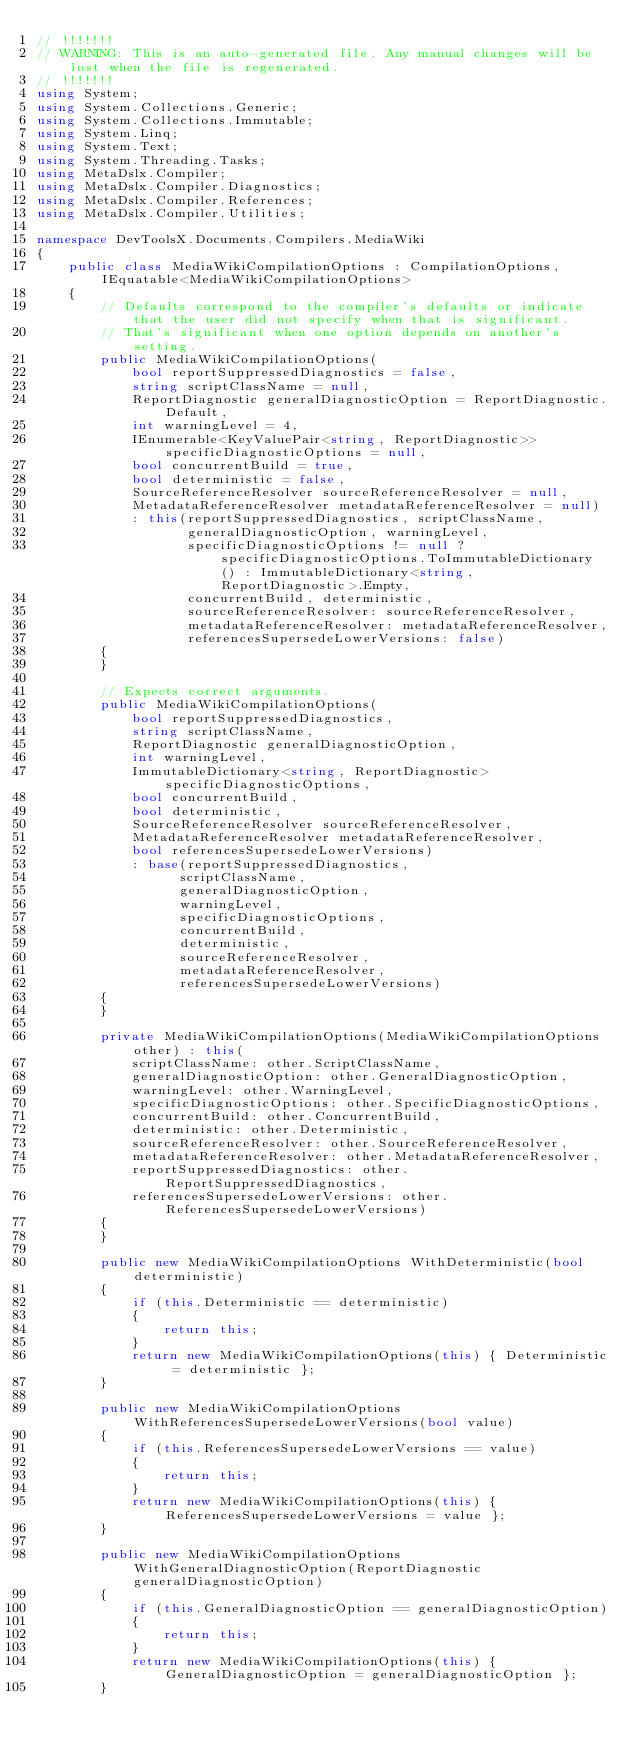<code> <loc_0><loc_0><loc_500><loc_500><_C#_>// !!!!!!!
// WARNING: This is an auto-generated file. Any manual changes will be lost when the file is regenerated.
// !!!!!!!
using System;
using System.Collections.Generic;
using System.Collections.Immutable;
using System.Linq;
using System.Text;
using System.Threading.Tasks;
using MetaDslx.Compiler;
using MetaDslx.Compiler.Diagnostics;
using MetaDslx.Compiler.References;
using MetaDslx.Compiler.Utilities;

namespace DevToolsX.Documents.Compilers.MediaWiki
{
    public class MediaWikiCompilationOptions : CompilationOptions, IEquatable<MediaWikiCompilationOptions>
    {
        // Defaults correspond to the compiler's defaults or indicate that the user did not specify when that is significant.
        // That's significant when one option depends on another's setting.
        public MediaWikiCompilationOptions(
            bool reportSuppressedDiagnostics = false,
            string scriptClassName = null,
            ReportDiagnostic generalDiagnosticOption = ReportDiagnostic.Default,
            int warningLevel = 4,
            IEnumerable<KeyValuePair<string, ReportDiagnostic>> specificDiagnosticOptions = null,
            bool concurrentBuild = true,
            bool deterministic = false,
            SourceReferenceResolver sourceReferenceResolver = null,
            MetadataReferenceResolver metadataReferenceResolver = null)
            : this(reportSuppressedDiagnostics, scriptClassName,
                   generalDiagnosticOption, warningLevel,
                   specificDiagnosticOptions != null ? specificDiagnosticOptions.ToImmutableDictionary() : ImmutableDictionary<string, ReportDiagnostic>.Empty, 
                   concurrentBuild, deterministic,
                   sourceReferenceResolver: sourceReferenceResolver,
                   metadataReferenceResolver: metadataReferenceResolver,
                   referencesSupersedeLowerVersions: false)
        {
        }

        // Expects correct arguments.
        public MediaWikiCompilationOptions(
            bool reportSuppressedDiagnostics,
            string scriptClassName,
            ReportDiagnostic generalDiagnosticOption,
            int warningLevel,
            ImmutableDictionary<string, ReportDiagnostic> specificDiagnosticOptions,
            bool concurrentBuild,
            bool deterministic,
            SourceReferenceResolver sourceReferenceResolver,
            MetadataReferenceResolver metadataReferenceResolver,
            bool referencesSupersedeLowerVersions)
            : base(reportSuppressedDiagnostics, 
                  scriptClassName,
                  generalDiagnosticOption,
                  warningLevel,
                  specificDiagnosticOptions,
                  concurrentBuild,
                  deterministic,
                  sourceReferenceResolver,
                  metadataReferenceResolver, 
                  referencesSupersedeLowerVersions)
        {
        }

        private MediaWikiCompilationOptions(MediaWikiCompilationOptions other) : this(
            scriptClassName: other.ScriptClassName,
            generalDiagnosticOption: other.GeneralDiagnosticOption,
            warningLevel: other.WarningLevel,
            specificDiagnosticOptions: other.SpecificDiagnosticOptions,
            concurrentBuild: other.ConcurrentBuild,
            deterministic: other.Deterministic,
            sourceReferenceResolver: other.SourceReferenceResolver,
            metadataReferenceResolver: other.MetadataReferenceResolver,
            reportSuppressedDiagnostics: other.ReportSuppressedDiagnostics,
            referencesSupersedeLowerVersions: other.ReferencesSupersedeLowerVersions)
        {
        }

        public new MediaWikiCompilationOptions WithDeterministic(bool deterministic)
        {
            if (this.Deterministic == deterministic)
            {
                return this;
            }
            return new MediaWikiCompilationOptions(this) { Deterministic = deterministic };
        }

        public new MediaWikiCompilationOptions WithReferencesSupersedeLowerVersions(bool value)
        {
            if (this.ReferencesSupersedeLowerVersions == value)
            {
                return this;
            }
            return new MediaWikiCompilationOptions(this) { ReferencesSupersedeLowerVersions = value };
        }

        public new MediaWikiCompilationOptions WithGeneralDiagnosticOption(ReportDiagnostic generalDiagnosticOption)
        {
            if (this.GeneralDiagnosticOption == generalDiagnosticOption)
            {
                return this;
            }
            return new MediaWikiCompilationOptions(this) { GeneralDiagnosticOption = generalDiagnosticOption };
        }
</code> 